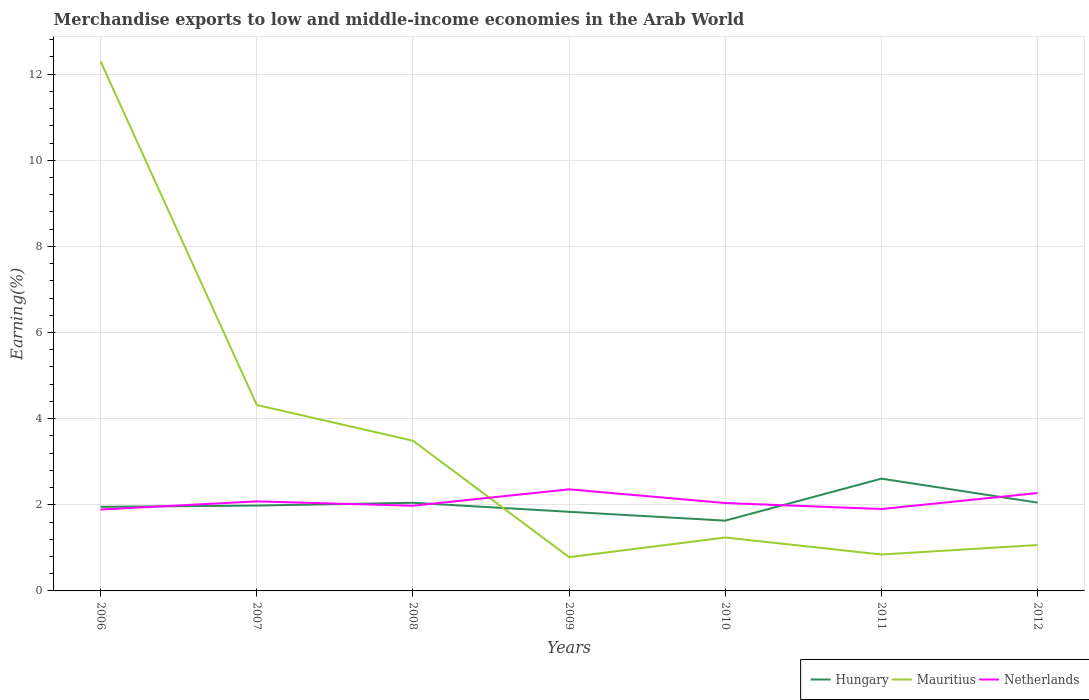Is the number of lines equal to the number of legend labels?
Offer a very short reply. Yes. Across all years, what is the maximum percentage of amount earned from merchandise exports in Mauritius?
Provide a short and direct response. 0.78. What is the total percentage of amount earned from merchandise exports in Mauritius in the graph?
Your answer should be compact. 2.7. What is the difference between the highest and the second highest percentage of amount earned from merchandise exports in Netherlands?
Provide a short and direct response. 0.47. What is the difference between the highest and the lowest percentage of amount earned from merchandise exports in Netherlands?
Keep it short and to the point. 3. Is the percentage of amount earned from merchandise exports in Netherlands strictly greater than the percentage of amount earned from merchandise exports in Mauritius over the years?
Offer a terse response. No. How many lines are there?
Give a very brief answer. 3. How many years are there in the graph?
Offer a very short reply. 7. What is the difference between two consecutive major ticks on the Y-axis?
Your answer should be very brief. 2. Are the values on the major ticks of Y-axis written in scientific E-notation?
Your answer should be compact. No. Does the graph contain grids?
Provide a short and direct response. Yes. Where does the legend appear in the graph?
Your answer should be very brief. Bottom right. What is the title of the graph?
Offer a terse response. Merchandise exports to low and middle-income economies in the Arab World. What is the label or title of the Y-axis?
Provide a short and direct response. Earning(%). What is the Earning(%) of Hungary in 2006?
Keep it short and to the point. 1.95. What is the Earning(%) in Mauritius in 2006?
Provide a succinct answer. 12.3. What is the Earning(%) of Netherlands in 2006?
Keep it short and to the point. 1.89. What is the Earning(%) in Hungary in 2007?
Give a very brief answer. 1.98. What is the Earning(%) in Mauritius in 2007?
Keep it short and to the point. 4.32. What is the Earning(%) in Netherlands in 2007?
Your answer should be compact. 2.08. What is the Earning(%) of Hungary in 2008?
Your response must be concise. 2.05. What is the Earning(%) in Mauritius in 2008?
Provide a short and direct response. 3.49. What is the Earning(%) in Netherlands in 2008?
Give a very brief answer. 1.98. What is the Earning(%) in Hungary in 2009?
Make the answer very short. 1.84. What is the Earning(%) of Mauritius in 2009?
Your response must be concise. 0.78. What is the Earning(%) of Netherlands in 2009?
Make the answer very short. 2.36. What is the Earning(%) in Hungary in 2010?
Your answer should be very brief. 1.63. What is the Earning(%) in Mauritius in 2010?
Your answer should be very brief. 1.24. What is the Earning(%) in Netherlands in 2010?
Your answer should be very brief. 2.04. What is the Earning(%) in Hungary in 2011?
Give a very brief answer. 2.61. What is the Earning(%) of Mauritius in 2011?
Offer a very short reply. 0.85. What is the Earning(%) of Netherlands in 2011?
Offer a terse response. 1.9. What is the Earning(%) in Hungary in 2012?
Your answer should be very brief. 2.05. What is the Earning(%) in Mauritius in 2012?
Your answer should be compact. 1.07. What is the Earning(%) of Netherlands in 2012?
Provide a short and direct response. 2.27. Across all years, what is the maximum Earning(%) of Hungary?
Offer a terse response. 2.61. Across all years, what is the maximum Earning(%) of Mauritius?
Offer a terse response. 12.3. Across all years, what is the maximum Earning(%) in Netherlands?
Keep it short and to the point. 2.36. Across all years, what is the minimum Earning(%) in Hungary?
Your answer should be compact. 1.63. Across all years, what is the minimum Earning(%) of Mauritius?
Your answer should be compact. 0.78. Across all years, what is the minimum Earning(%) in Netherlands?
Your answer should be compact. 1.89. What is the total Earning(%) of Hungary in the graph?
Your answer should be compact. 14.11. What is the total Earning(%) of Mauritius in the graph?
Make the answer very short. 24.04. What is the total Earning(%) of Netherlands in the graph?
Offer a very short reply. 14.52. What is the difference between the Earning(%) of Hungary in 2006 and that in 2007?
Provide a succinct answer. -0.03. What is the difference between the Earning(%) in Mauritius in 2006 and that in 2007?
Provide a succinct answer. 7.98. What is the difference between the Earning(%) of Netherlands in 2006 and that in 2007?
Offer a terse response. -0.19. What is the difference between the Earning(%) of Hungary in 2006 and that in 2008?
Give a very brief answer. -0.09. What is the difference between the Earning(%) of Mauritius in 2006 and that in 2008?
Ensure brevity in your answer.  8.81. What is the difference between the Earning(%) of Netherlands in 2006 and that in 2008?
Make the answer very short. -0.09. What is the difference between the Earning(%) in Hungary in 2006 and that in 2009?
Your response must be concise. 0.12. What is the difference between the Earning(%) of Mauritius in 2006 and that in 2009?
Keep it short and to the point. 11.51. What is the difference between the Earning(%) in Netherlands in 2006 and that in 2009?
Give a very brief answer. -0.47. What is the difference between the Earning(%) of Hungary in 2006 and that in 2010?
Offer a very short reply. 0.32. What is the difference between the Earning(%) of Mauritius in 2006 and that in 2010?
Provide a succinct answer. 11.06. What is the difference between the Earning(%) of Netherlands in 2006 and that in 2010?
Provide a succinct answer. -0.15. What is the difference between the Earning(%) in Hungary in 2006 and that in 2011?
Your answer should be very brief. -0.65. What is the difference between the Earning(%) in Mauritius in 2006 and that in 2011?
Make the answer very short. 11.45. What is the difference between the Earning(%) of Netherlands in 2006 and that in 2011?
Ensure brevity in your answer.  -0.01. What is the difference between the Earning(%) in Hungary in 2006 and that in 2012?
Offer a terse response. -0.1. What is the difference between the Earning(%) of Mauritius in 2006 and that in 2012?
Keep it short and to the point. 11.23. What is the difference between the Earning(%) in Netherlands in 2006 and that in 2012?
Your answer should be compact. -0.38. What is the difference between the Earning(%) in Hungary in 2007 and that in 2008?
Your answer should be compact. -0.06. What is the difference between the Earning(%) in Mauritius in 2007 and that in 2008?
Give a very brief answer. 0.83. What is the difference between the Earning(%) of Netherlands in 2007 and that in 2008?
Offer a very short reply. 0.1. What is the difference between the Earning(%) of Hungary in 2007 and that in 2009?
Your answer should be very brief. 0.14. What is the difference between the Earning(%) in Mauritius in 2007 and that in 2009?
Your answer should be compact. 3.53. What is the difference between the Earning(%) of Netherlands in 2007 and that in 2009?
Keep it short and to the point. -0.28. What is the difference between the Earning(%) of Hungary in 2007 and that in 2010?
Keep it short and to the point. 0.35. What is the difference between the Earning(%) in Mauritius in 2007 and that in 2010?
Offer a terse response. 3.08. What is the difference between the Earning(%) of Netherlands in 2007 and that in 2010?
Provide a short and direct response. 0.04. What is the difference between the Earning(%) in Hungary in 2007 and that in 2011?
Provide a short and direct response. -0.63. What is the difference between the Earning(%) in Mauritius in 2007 and that in 2011?
Your answer should be very brief. 3.47. What is the difference between the Earning(%) in Netherlands in 2007 and that in 2011?
Give a very brief answer. 0.18. What is the difference between the Earning(%) of Hungary in 2007 and that in 2012?
Give a very brief answer. -0.07. What is the difference between the Earning(%) of Mauritius in 2007 and that in 2012?
Your answer should be compact. 3.25. What is the difference between the Earning(%) in Netherlands in 2007 and that in 2012?
Make the answer very short. -0.19. What is the difference between the Earning(%) of Hungary in 2008 and that in 2009?
Offer a terse response. 0.21. What is the difference between the Earning(%) of Mauritius in 2008 and that in 2009?
Your response must be concise. 2.7. What is the difference between the Earning(%) in Netherlands in 2008 and that in 2009?
Provide a short and direct response. -0.38. What is the difference between the Earning(%) of Hungary in 2008 and that in 2010?
Make the answer very short. 0.41. What is the difference between the Earning(%) of Mauritius in 2008 and that in 2010?
Provide a succinct answer. 2.25. What is the difference between the Earning(%) in Netherlands in 2008 and that in 2010?
Provide a succinct answer. -0.06. What is the difference between the Earning(%) of Hungary in 2008 and that in 2011?
Ensure brevity in your answer.  -0.56. What is the difference between the Earning(%) of Mauritius in 2008 and that in 2011?
Keep it short and to the point. 2.64. What is the difference between the Earning(%) in Netherlands in 2008 and that in 2011?
Keep it short and to the point. 0.08. What is the difference between the Earning(%) of Hungary in 2008 and that in 2012?
Make the answer very short. -0. What is the difference between the Earning(%) of Mauritius in 2008 and that in 2012?
Ensure brevity in your answer.  2.42. What is the difference between the Earning(%) in Netherlands in 2008 and that in 2012?
Your answer should be very brief. -0.29. What is the difference between the Earning(%) in Hungary in 2009 and that in 2010?
Offer a very short reply. 0.21. What is the difference between the Earning(%) of Mauritius in 2009 and that in 2010?
Offer a terse response. -0.46. What is the difference between the Earning(%) in Netherlands in 2009 and that in 2010?
Your response must be concise. 0.32. What is the difference between the Earning(%) of Hungary in 2009 and that in 2011?
Your answer should be very brief. -0.77. What is the difference between the Earning(%) in Mauritius in 2009 and that in 2011?
Your response must be concise. -0.06. What is the difference between the Earning(%) of Netherlands in 2009 and that in 2011?
Offer a very short reply. 0.46. What is the difference between the Earning(%) of Hungary in 2009 and that in 2012?
Your response must be concise. -0.21. What is the difference between the Earning(%) in Mauritius in 2009 and that in 2012?
Make the answer very short. -0.28. What is the difference between the Earning(%) in Netherlands in 2009 and that in 2012?
Your answer should be compact. 0.09. What is the difference between the Earning(%) in Hungary in 2010 and that in 2011?
Ensure brevity in your answer.  -0.97. What is the difference between the Earning(%) in Mauritius in 2010 and that in 2011?
Provide a short and direct response. 0.4. What is the difference between the Earning(%) of Netherlands in 2010 and that in 2011?
Provide a succinct answer. 0.14. What is the difference between the Earning(%) in Hungary in 2010 and that in 2012?
Ensure brevity in your answer.  -0.42. What is the difference between the Earning(%) of Mauritius in 2010 and that in 2012?
Ensure brevity in your answer.  0.17. What is the difference between the Earning(%) of Netherlands in 2010 and that in 2012?
Keep it short and to the point. -0.23. What is the difference between the Earning(%) of Hungary in 2011 and that in 2012?
Offer a terse response. 0.56. What is the difference between the Earning(%) of Mauritius in 2011 and that in 2012?
Give a very brief answer. -0.22. What is the difference between the Earning(%) in Netherlands in 2011 and that in 2012?
Offer a very short reply. -0.37. What is the difference between the Earning(%) of Hungary in 2006 and the Earning(%) of Mauritius in 2007?
Make the answer very short. -2.37. What is the difference between the Earning(%) of Hungary in 2006 and the Earning(%) of Netherlands in 2007?
Give a very brief answer. -0.13. What is the difference between the Earning(%) in Mauritius in 2006 and the Earning(%) in Netherlands in 2007?
Give a very brief answer. 10.22. What is the difference between the Earning(%) in Hungary in 2006 and the Earning(%) in Mauritius in 2008?
Your response must be concise. -1.54. What is the difference between the Earning(%) of Hungary in 2006 and the Earning(%) of Netherlands in 2008?
Your answer should be compact. -0.03. What is the difference between the Earning(%) in Mauritius in 2006 and the Earning(%) in Netherlands in 2008?
Ensure brevity in your answer.  10.32. What is the difference between the Earning(%) in Hungary in 2006 and the Earning(%) in Mauritius in 2009?
Offer a terse response. 1.17. What is the difference between the Earning(%) in Hungary in 2006 and the Earning(%) in Netherlands in 2009?
Give a very brief answer. -0.41. What is the difference between the Earning(%) in Mauritius in 2006 and the Earning(%) in Netherlands in 2009?
Keep it short and to the point. 9.94. What is the difference between the Earning(%) in Hungary in 2006 and the Earning(%) in Mauritius in 2010?
Ensure brevity in your answer.  0.71. What is the difference between the Earning(%) of Hungary in 2006 and the Earning(%) of Netherlands in 2010?
Offer a very short reply. -0.09. What is the difference between the Earning(%) in Mauritius in 2006 and the Earning(%) in Netherlands in 2010?
Provide a succinct answer. 10.25. What is the difference between the Earning(%) in Hungary in 2006 and the Earning(%) in Mauritius in 2011?
Make the answer very short. 1.11. What is the difference between the Earning(%) of Hungary in 2006 and the Earning(%) of Netherlands in 2011?
Provide a succinct answer. 0.05. What is the difference between the Earning(%) of Mauritius in 2006 and the Earning(%) of Netherlands in 2011?
Offer a terse response. 10.39. What is the difference between the Earning(%) in Hungary in 2006 and the Earning(%) in Mauritius in 2012?
Ensure brevity in your answer.  0.89. What is the difference between the Earning(%) in Hungary in 2006 and the Earning(%) in Netherlands in 2012?
Provide a succinct answer. -0.32. What is the difference between the Earning(%) in Mauritius in 2006 and the Earning(%) in Netherlands in 2012?
Your answer should be very brief. 10.02. What is the difference between the Earning(%) in Hungary in 2007 and the Earning(%) in Mauritius in 2008?
Offer a terse response. -1.51. What is the difference between the Earning(%) in Hungary in 2007 and the Earning(%) in Netherlands in 2008?
Offer a terse response. 0. What is the difference between the Earning(%) of Mauritius in 2007 and the Earning(%) of Netherlands in 2008?
Make the answer very short. 2.34. What is the difference between the Earning(%) of Hungary in 2007 and the Earning(%) of Mauritius in 2009?
Make the answer very short. 1.2. What is the difference between the Earning(%) in Hungary in 2007 and the Earning(%) in Netherlands in 2009?
Give a very brief answer. -0.38. What is the difference between the Earning(%) in Mauritius in 2007 and the Earning(%) in Netherlands in 2009?
Make the answer very short. 1.96. What is the difference between the Earning(%) in Hungary in 2007 and the Earning(%) in Mauritius in 2010?
Make the answer very short. 0.74. What is the difference between the Earning(%) of Hungary in 2007 and the Earning(%) of Netherlands in 2010?
Ensure brevity in your answer.  -0.06. What is the difference between the Earning(%) in Mauritius in 2007 and the Earning(%) in Netherlands in 2010?
Keep it short and to the point. 2.28. What is the difference between the Earning(%) in Hungary in 2007 and the Earning(%) in Mauritius in 2011?
Give a very brief answer. 1.14. What is the difference between the Earning(%) of Hungary in 2007 and the Earning(%) of Netherlands in 2011?
Provide a succinct answer. 0.08. What is the difference between the Earning(%) of Mauritius in 2007 and the Earning(%) of Netherlands in 2011?
Ensure brevity in your answer.  2.42. What is the difference between the Earning(%) of Hungary in 2007 and the Earning(%) of Mauritius in 2012?
Provide a succinct answer. 0.92. What is the difference between the Earning(%) in Hungary in 2007 and the Earning(%) in Netherlands in 2012?
Offer a terse response. -0.29. What is the difference between the Earning(%) of Mauritius in 2007 and the Earning(%) of Netherlands in 2012?
Make the answer very short. 2.05. What is the difference between the Earning(%) in Hungary in 2008 and the Earning(%) in Mauritius in 2009?
Offer a very short reply. 1.26. What is the difference between the Earning(%) of Hungary in 2008 and the Earning(%) of Netherlands in 2009?
Make the answer very short. -0.31. What is the difference between the Earning(%) in Mauritius in 2008 and the Earning(%) in Netherlands in 2009?
Your answer should be very brief. 1.13. What is the difference between the Earning(%) of Hungary in 2008 and the Earning(%) of Mauritius in 2010?
Provide a short and direct response. 0.81. What is the difference between the Earning(%) of Hungary in 2008 and the Earning(%) of Netherlands in 2010?
Your response must be concise. 0.01. What is the difference between the Earning(%) of Mauritius in 2008 and the Earning(%) of Netherlands in 2010?
Provide a short and direct response. 1.45. What is the difference between the Earning(%) in Hungary in 2008 and the Earning(%) in Mauritius in 2011?
Offer a very short reply. 1.2. What is the difference between the Earning(%) in Hungary in 2008 and the Earning(%) in Netherlands in 2011?
Provide a short and direct response. 0.14. What is the difference between the Earning(%) in Mauritius in 2008 and the Earning(%) in Netherlands in 2011?
Offer a very short reply. 1.59. What is the difference between the Earning(%) in Hungary in 2008 and the Earning(%) in Mauritius in 2012?
Your answer should be very brief. 0.98. What is the difference between the Earning(%) of Hungary in 2008 and the Earning(%) of Netherlands in 2012?
Your answer should be compact. -0.23. What is the difference between the Earning(%) in Mauritius in 2008 and the Earning(%) in Netherlands in 2012?
Offer a very short reply. 1.22. What is the difference between the Earning(%) in Hungary in 2009 and the Earning(%) in Mauritius in 2010?
Keep it short and to the point. 0.6. What is the difference between the Earning(%) in Hungary in 2009 and the Earning(%) in Netherlands in 2010?
Give a very brief answer. -0.2. What is the difference between the Earning(%) of Mauritius in 2009 and the Earning(%) of Netherlands in 2010?
Give a very brief answer. -1.26. What is the difference between the Earning(%) of Hungary in 2009 and the Earning(%) of Mauritius in 2011?
Provide a succinct answer. 0.99. What is the difference between the Earning(%) in Hungary in 2009 and the Earning(%) in Netherlands in 2011?
Your answer should be very brief. -0.06. What is the difference between the Earning(%) of Mauritius in 2009 and the Earning(%) of Netherlands in 2011?
Offer a very short reply. -1.12. What is the difference between the Earning(%) of Hungary in 2009 and the Earning(%) of Mauritius in 2012?
Give a very brief answer. 0.77. What is the difference between the Earning(%) of Hungary in 2009 and the Earning(%) of Netherlands in 2012?
Make the answer very short. -0.43. What is the difference between the Earning(%) of Mauritius in 2009 and the Earning(%) of Netherlands in 2012?
Your response must be concise. -1.49. What is the difference between the Earning(%) of Hungary in 2010 and the Earning(%) of Mauritius in 2011?
Your answer should be very brief. 0.79. What is the difference between the Earning(%) in Hungary in 2010 and the Earning(%) in Netherlands in 2011?
Offer a terse response. -0.27. What is the difference between the Earning(%) of Mauritius in 2010 and the Earning(%) of Netherlands in 2011?
Your answer should be very brief. -0.66. What is the difference between the Earning(%) of Hungary in 2010 and the Earning(%) of Mauritius in 2012?
Provide a short and direct response. 0.57. What is the difference between the Earning(%) of Hungary in 2010 and the Earning(%) of Netherlands in 2012?
Offer a very short reply. -0.64. What is the difference between the Earning(%) of Mauritius in 2010 and the Earning(%) of Netherlands in 2012?
Give a very brief answer. -1.03. What is the difference between the Earning(%) of Hungary in 2011 and the Earning(%) of Mauritius in 2012?
Offer a terse response. 1.54. What is the difference between the Earning(%) in Hungary in 2011 and the Earning(%) in Netherlands in 2012?
Make the answer very short. 0.34. What is the difference between the Earning(%) of Mauritius in 2011 and the Earning(%) of Netherlands in 2012?
Keep it short and to the point. -1.43. What is the average Earning(%) in Hungary per year?
Make the answer very short. 2.02. What is the average Earning(%) of Mauritius per year?
Give a very brief answer. 3.43. What is the average Earning(%) of Netherlands per year?
Make the answer very short. 2.07. In the year 2006, what is the difference between the Earning(%) of Hungary and Earning(%) of Mauritius?
Ensure brevity in your answer.  -10.34. In the year 2006, what is the difference between the Earning(%) in Hungary and Earning(%) in Netherlands?
Make the answer very short. 0.06. In the year 2006, what is the difference between the Earning(%) of Mauritius and Earning(%) of Netherlands?
Give a very brief answer. 10.41. In the year 2007, what is the difference between the Earning(%) in Hungary and Earning(%) in Mauritius?
Offer a very short reply. -2.34. In the year 2007, what is the difference between the Earning(%) in Hungary and Earning(%) in Netherlands?
Provide a succinct answer. -0.1. In the year 2007, what is the difference between the Earning(%) in Mauritius and Earning(%) in Netherlands?
Ensure brevity in your answer.  2.24. In the year 2008, what is the difference between the Earning(%) of Hungary and Earning(%) of Mauritius?
Make the answer very short. -1.44. In the year 2008, what is the difference between the Earning(%) in Hungary and Earning(%) in Netherlands?
Offer a terse response. 0.07. In the year 2008, what is the difference between the Earning(%) of Mauritius and Earning(%) of Netherlands?
Your answer should be very brief. 1.51. In the year 2009, what is the difference between the Earning(%) in Hungary and Earning(%) in Mauritius?
Your answer should be compact. 1.05. In the year 2009, what is the difference between the Earning(%) of Hungary and Earning(%) of Netherlands?
Give a very brief answer. -0.52. In the year 2009, what is the difference between the Earning(%) of Mauritius and Earning(%) of Netherlands?
Make the answer very short. -1.57. In the year 2010, what is the difference between the Earning(%) in Hungary and Earning(%) in Mauritius?
Your response must be concise. 0.39. In the year 2010, what is the difference between the Earning(%) in Hungary and Earning(%) in Netherlands?
Your response must be concise. -0.41. In the year 2010, what is the difference between the Earning(%) of Mauritius and Earning(%) of Netherlands?
Ensure brevity in your answer.  -0.8. In the year 2011, what is the difference between the Earning(%) in Hungary and Earning(%) in Mauritius?
Your answer should be very brief. 1.76. In the year 2011, what is the difference between the Earning(%) of Hungary and Earning(%) of Netherlands?
Give a very brief answer. 0.71. In the year 2011, what is the difference between the Earning(%) of Mauritius and Earning(%) of Netherlands?
Offer a very short reply. -1.06. In the year 2012, what is the difference between the Earning(%) of Hungary and Earning(%) of Mauritius?
Ensure brevity in your answer.  0.98. In the year 2012, what is the difference between the Earning(%) in Hungary and Earning(%) in Netherlands?
Provide a short and direct response. -0.22. In the year 2012, what is the difference between the Earning(%) in Mauritius and Earning(%) in Netherlands?
Ensure brevity in your answer.  -1.21. What is the ratio of the Earning(%) of Hungary in 2006 to that in 2007?
Provide a succinct answer. 0.99. What is the ratio of the Earning(%) of Mauritius in 2006 to that in 2007?
Make the answer very short. 2.85. What is the ratio of the Earning(%) of Netherlands in 2006 to that in 2007?
Ensure brevity in your answer.  0.91. What is the ratio of the Earning(%) of Hungary in 2006 to that in 2008?
Make the answer very short. 0.95. What is the ratio of the Earning(%) in Mauritius in 2006 to that in 2008?
Ensure brevity in your answer.  3.53. What is the ratio of the Earning(%) of Netherlands in 2006 to that in 2008?
Ensure brevity in your answer.  0.96. What is the ratio of the Earning(%) in Hungary in 2006 to that in 2009?
Ensure brevity in your answer.  1.06. What is the ratio of the Earning(%) in Mauritius in 2006 to that in 2009?
Keep it short and to the point. 15.68. What is the ratio of the Earning(%) in Netherlands in 2006 to that in 2009?
Give a very brief answer. 0.8. What is the ratio of the Earning(%) of Hungary in 2006 to that in 2010?
Your answer should be very brief. 1.2. What is the ratio of the Earning(%) of Mauritius in 2006 to that in 2010?
Keep it short and to the point. 9.91. What is the ratio of the Earning(%) of Netherlands in 2006 to that in 2010?
Ensure brevity in your answer.  0.93. What is the ratio of the Earning(%) of Hungary in 2006 to that in 2011?
Provide a short and direct response. 0.75. What is the ratio of the Earning(%) of Mauritius in 2006 to that in 2011?
Give a very brief answer. 14.54. What is the ratio of the Earning(%) of Netherlands in 2006 to that in 2011?
Keep it short and to the point. 0.99. What is the ratio of the Earning(%) in Mauritius in 2006 to that in 2012?
Ensure brevity in your answer.  11.53. What is the ratio of the Earning(%) of Netherlands in 2006 to that in 2012?
Keep it short and to the point. 0.83. What is the ratio of the Earning(%) of Hungary in 2007 to that in 2008?
Provide a short and direct response. 0.97. What is the ratio of the Earning(%) in Mauritius in 2007 to that in 2008?
Offer a very short reply. 1.24. What is the ratio of the Earning(%) in Netherlands in 2007 to that in 2008?
Keep it short and to the point. 1.05. What is the ratio of the Earning(%) in Hungary in 2007 to that in 2009?
Keep it short and to the point. 1.08. What is the ratio of the Earning(%) of Mauritius in 2007 to that in 2009?
Your answer should be very brief. 5.51. What is the ratio of the Earning(%) of Netherlands in 2007 to that in 2009?
Provide a succinct answer. 0.88. What is the ratio of the Earning(%) of Hungary in 2007 to that in 2010?
Ensure brevity in your answer.  1.21. What is the ratio of the Earning(%) in Mauritius in 2007 to that in 2010?
Your answer should be compact. 3.48. What is the ratio of the Earning(%) of Netherlands in 2007 to that in 2010?
Offer a very short reply. 1.02. What is the ratio of the Earning(%) in Hungary in 2007 to that in 2011?
Keep it short and to the point. 0.76. What is the ratio of the Earning(%) in Mauritius in 2007 to that in 2011?
Keep it short and to the point. 5.11. What is the ratio of the Earning(%) of Netherlands in 2007 to that in 2011?
Ensure brevity in your answer.  1.09. What is the ratio of the Earning(%) in Hungary in 2007 to that in 2012?
Offer a very short reply. 0.97. What is the ratio of the Earning(%) in Mauritius in 2007 to that in 2012?
Ensure brevity in your answer.  4.05. What is the ratio of the Earning(%) of Netherlands in 2007 to that in 2012?
Give a very brief answer. 0.92. What is the ratio of the Earning(%) of Hungary in 2008 to that in 2009?
Your answer should be very brief. 1.11. What is the ratio of the Earning(%) of Mauritius in 2008 to that in 2009?
Make the answer very short. 4.45. What is the ratio of the Earning(%) of Netherlands in 2008 to that in 2009?
Provide a succinct answer. 0.84. What is the ratio of the Earning(%) in Hungary in 2008 to that in 2010?
Ensure brevity in your answer.  1.25. What is the ratio of the Earning(%) of Mauritius in 2008 to that in 2010?
Your answer should be compact. 2.81. What is the ratio of the Earning(%) of Netherlands in 2008 to that in 2010?
Offer a terse response. 0.97. What is the ratio of the Earning(%) in Hungary in 2008 to that in 2011?
Offer a terse response. 0.79. What is the ratio of the Earning(%) in Mauritius in 2008 to that in 2011?
Offer a terse response. 4.13. What is the ratio of the Earning(%) in Netherlands in 2008 to that in 2011?
Offer a very short reply. 1.04. What is the ratio of the Earning(%) of Hungary in 2008 to that in 2012?
Offer a very short reply. 1. What is the ratio of the Earning(%) of Mauritius in 2008 to that in 2012?
Your answer should be compact. 3.27. What is the ratio of the Earning(%) of Netherlands in 2008 to that in 2012?
Keep it short and to the point. 0.87. What is the ratio of the Earning(%) in Hungary in 2009 to that in 2010?
Your answer should be compact. 1.13. What is the ratio of the Earning(%) of Mauritius in 2009 to that in 2010?
Offer a very short reply. 0.63. What is the ratio of the Earning(%) of Netherlands in 2009 to that in 2010?
Give a very brief answer. 1.16. What is the ratio of the Earning(%) of Hungary in 2009 to that in 2011?
Provide a short and direct response. 0.7. What is the ratio of the Earning(%) of Mauritius in 2009 to that in 2011?
Offer a terse response. 0.93. What is the ratio of the Earning(%) in Netherlands in 2009 to that in 2011?
Ensure brevity in your answer.  1.24. What is the ratio of the Earning(%) of Hungary in 2009 to that in 2012?
Offer a very short reply. 0.9. What is the ratio of the Earning(%) in Mauritius in 2009 to that in 2012?
Your answer should be compact. 0.74. What is the ratio of the Earning(%) of Netherlands in 2009 to that in 2012?
Provide a succinct answer. 1.04. What is the ratio of the Earning(%) in Hungary in 2010 to that in 2011?
Your answer should be compact. 0.63. What is the ratio of the Earning(%) in Mauritius in 2010 to that in 2011?
Ensure brevity in your answer.  1.47. What is the ratio of the Earning(%) of Netherlands in 2010 to that in 2011?
Offer a terse response. 1.07. What is the ratio of the Earning(%) of Hungary in 2010 to that in 2012?
Keep it short and to the point. 0.8. What is the ratio of the Earning(%) of Mauritius in 2010 to that in 2012?
Provide a short and direct response. 1.16. What is the ratio of the Earning(%) in Netherlands in 2010 to that in 2012?
Keep it short and to the point. 0.9. What is the ratio of the Earning(%) of Hungary in 2011 to that in 2012?
Your answer should be very brief. 1.27. What is the ratio of the Earning(%) of Mauritius in 2011 to that in 2012?
Your answer should be very brief. 0.79. What is the ratio of the Earning(%) of Netherlands in 2011 to that in 2012?
Give a very brief answer. 0.84. What is the difference between the highest and the second highest Earning(%) of Hungary?
Your answer should be very brief. 0.56. What is the difference between the highest and the second highest Earning(%) of Mauritius?
Provide a succinct answer. 7.98. What is the difference between the highest and the second highest Earning(%) of Netherlands?
Keep it short and to the point. 0.09. What is the difference between the highest and the lowest Earning(%) in Mauritius?
Provide a succinct answer. 11.51. What is the difference between the highest and the lowest Earning(%) of Netherlands?
Your response must be concise. 0.47. 